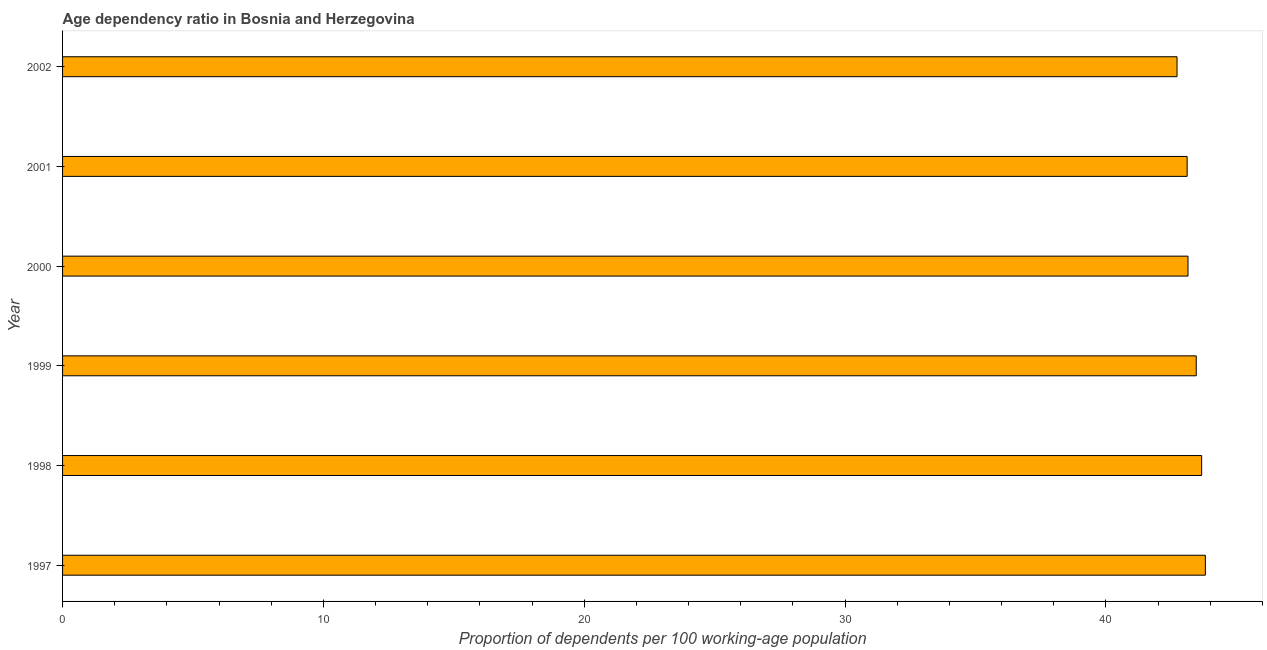What is the title of the graph?
Your answer should be very brief. Age dependency ratio in Bosnia and Herzegovina. What is the label or title of the X-axis?
Provide a short and direct response. Proportion of dependents per 100 working-age population. What is the label or title of the Y-axis?
Keep it short and to the point. Year. What is the age dependency ratio in 1997?
Offer a very short reply. 43.81. Across all years, what is the maximum age dependency ratio?
Offer a terse response. 43.81. Across all years, what is the minimum age dependency ratio?
Offer a very short reply. 42.73. In which year was the age dependency ratio maximum?
Offer a very short reply. 1997. What is the sum of the age dependency ratio?
Your answer should be very brief. 259.94. What is the difference between the age dependency ratio in 1998 and 2001?
Offer a very short reply. 0.56. What is the average age dependency ratio per year?
Your answer should be compact. 43.32. What is the median age dependency ratio?
Give a very brief answer. 43.31. In how many years, is the age dependency ratio greater than 6 ?
Offer a very short reply. 6. What is the ratio of the age dependency ratio in 1998 to that in 2001?
Make the answer very short. 1.01. Is the age dependency ratio in 1997 less than that in 1999?
Keep it short and to the point. No. What is the difference between the highest and the second highest age dependency ratio?
Offer a very short reply. 0.14. What is the difference between the highest and the lowest age dependency ratio?
Your answer should be compact. 1.09. Are all the bars in the graph horizontal?
Provide a short and direct response. Yes. How many years are there in the graph?
Your response must be concise. 6. Are the values on the major ticks of X-axis written in scientific E-notation?
Ensure brevity in your answer.  No. What is the Proportion of dependents per 100 working-age population in 1997?
Provide a succinct answer. 43.81. What is the Proportion of dependents per 100 working-age population in 1998?
Offer a terse response. 43.67. What is the Proportion of dependents per 100 working-age population in 1999?
Your answer should be compact. 43.46. What is the Proportion of dependents per 100 working-age population of 2000?
Your answer should be very brief. 43.15. What is the Proportion of dependents per 100 working-age population in 2001?
Provide a short and direct response. 43.12. What is the Proportion of dependents per 100 working-age population of 2002?
Offer a very short reply. 42.73. What is the difference between the Proportion of dependents per 100 working-age population in 1997 and 1998?
Keep it short and to the point. 0.14. What is the difference between the Proportion of dependents per 100 working-age population in 1997 and 1999?
Your response must be concise. 0.35. What is the difference between the Proportion of dependents per 100 working-age population in 1997 and 2000?
Ensure brevity in your answer.  0.67. What is the difference between the Proportion of dependents per 100 working-age population in 1997 and 2001?
Ensure brevity in your answer.  0.7. What is the difference between the Proportion of dependents per 100 working-age population in 1997 and 2002?
Make the answer very short. 1.09. What is the difference between the Proportion of dependents per 100 working-age population in 1998 and 1999?
Provide a short and direct response. 0.21. What is the difference between the Proportion of dependents per 100 working-age population in 1998 and 2000?
Offer a terse response. 0.52. What is the difference between the Proportion of dependents per 100 working-age population in 1998 and 2001?
Your response must be concise. 0.56. What is the difference between the Proportion of dependents per 100 working-age population in 1998 and 2002?
Offer a terse response. 0.94. What is the difference between the Proportion of dependents per 100 working-age population in 1999 and 2000?
Offer a very short reply. 0.32. What is the difference between the Proportion of dependents per 100 working-age population in 1999 and 2001?
Provide a succinct answer. 0.35. What is the difference between the Proportion of dependents per 100 working-age population in 1999 and 2002?
Offer a very short reply. 0.74. What is the difference between the Proportion of dependents per 100 working-age population in 2000 and 2001?
Offer a very short reply. 0.03. What is the difference between the Proportion of dependents per 100 working-age population in 2000 and 2002?
Give a very brief answer. 0.42. What is the difference between the Proportion of dependents per 100 working-age population in 2001 and 2002?
Make the answer very short. 0.39. What is the ratio of the Proportion of dependents per 100 working-age population in 1997 to that in 1999?
Provide a succinct answer. 1.01. What is the ratio of the Proportion of dependents per 100 working-age population in 1998 to that in 2000?
Offer a terse response. 1.01. What is the ratio of the Proportion of dependents per 100 working-age population in 1998 to that in 2002?
Offer a very short reply. 1.02. What is the ratio of the Proportion of dependents per 100 working-age population in 1999 to that in 2000?
Provide a short and direct response. 1.01. What is the ratio of the Proportion of dependents per 100 working-age population in 2000 to that in 2002?
Your answer should be compact. 1.01. What is the ratio of the Proportion of dependents per 100 working-age population in 2001 to that in 2002?
Ensure brevity in your answer.  1.01. 